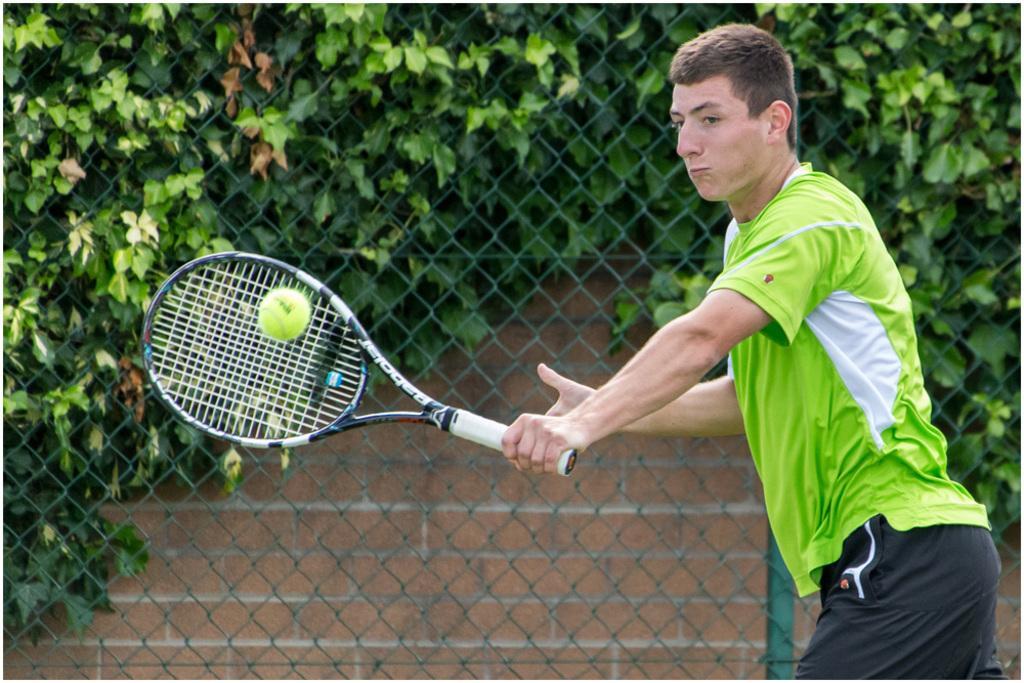In one or two sentences, can you explain what this image depicts? this picture shows a man playing tennis with a bat and we see few plants back of him and a metal fence 